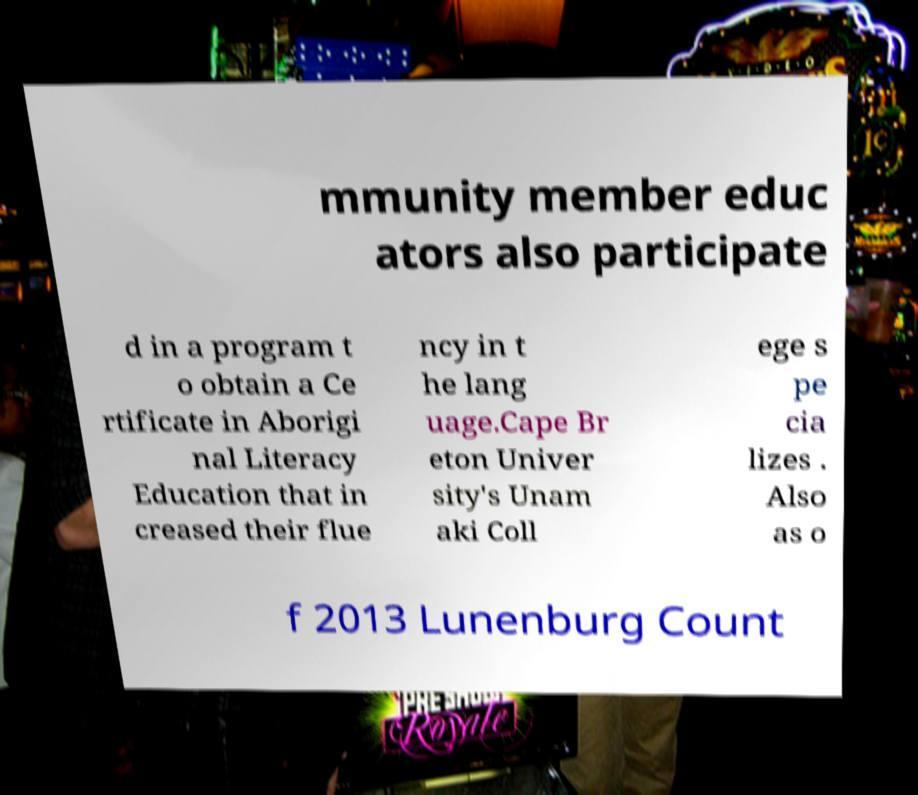There's text embedded in this image that I need extracted. Can you transcribe it verbatim? mmunity member educ ators also participate d in a program t o obtain a Ce rtificate in Aborigi nal Literacy Education that in creased their flue ncy in t he lang uage.Cape Br eton Univer sity's Unam aki Coll ege s pe cia lizes . Also as o f 2013 Lunenburg Count 